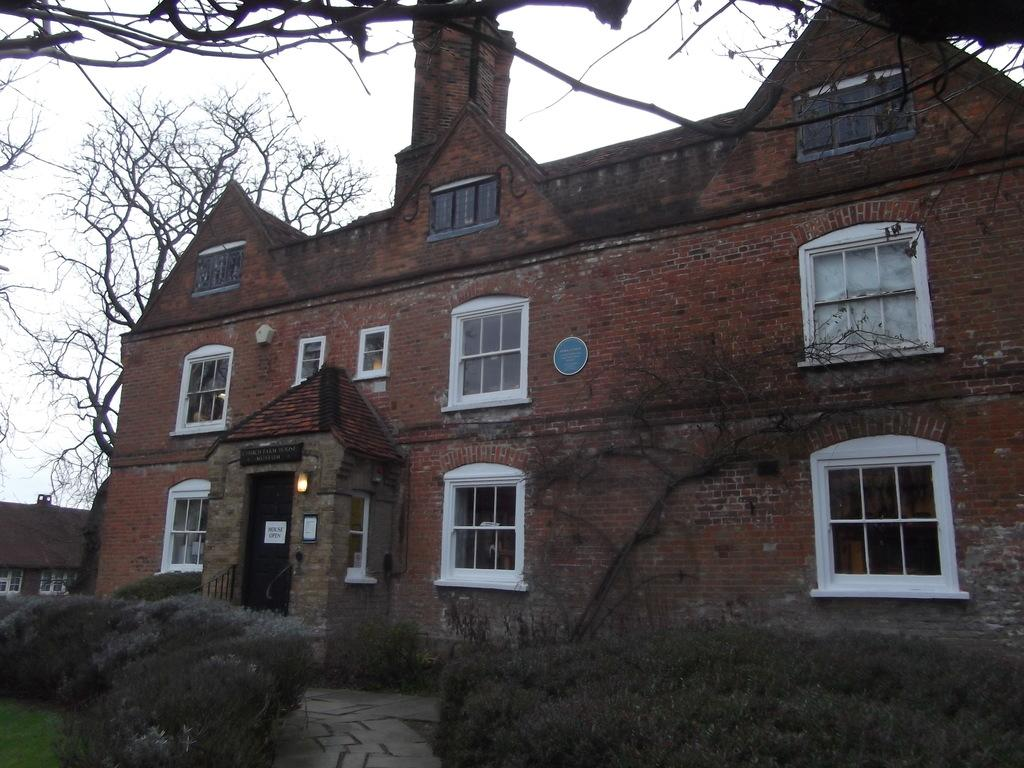What type of structure is present in the image? There is a building in the image. What can be seen on the ground in the image? There is a walkway in the image. What type of vegetation is visible in the background of the image? There are trees visible in the background of the image. What is the condition of the sky in the image? The sky is clear in the image. What is the purpose of the cannon in the image? There is no cannon present in the image. How many ladybugs can be seen on the building in the image? There are no ladybugs present in the image. 